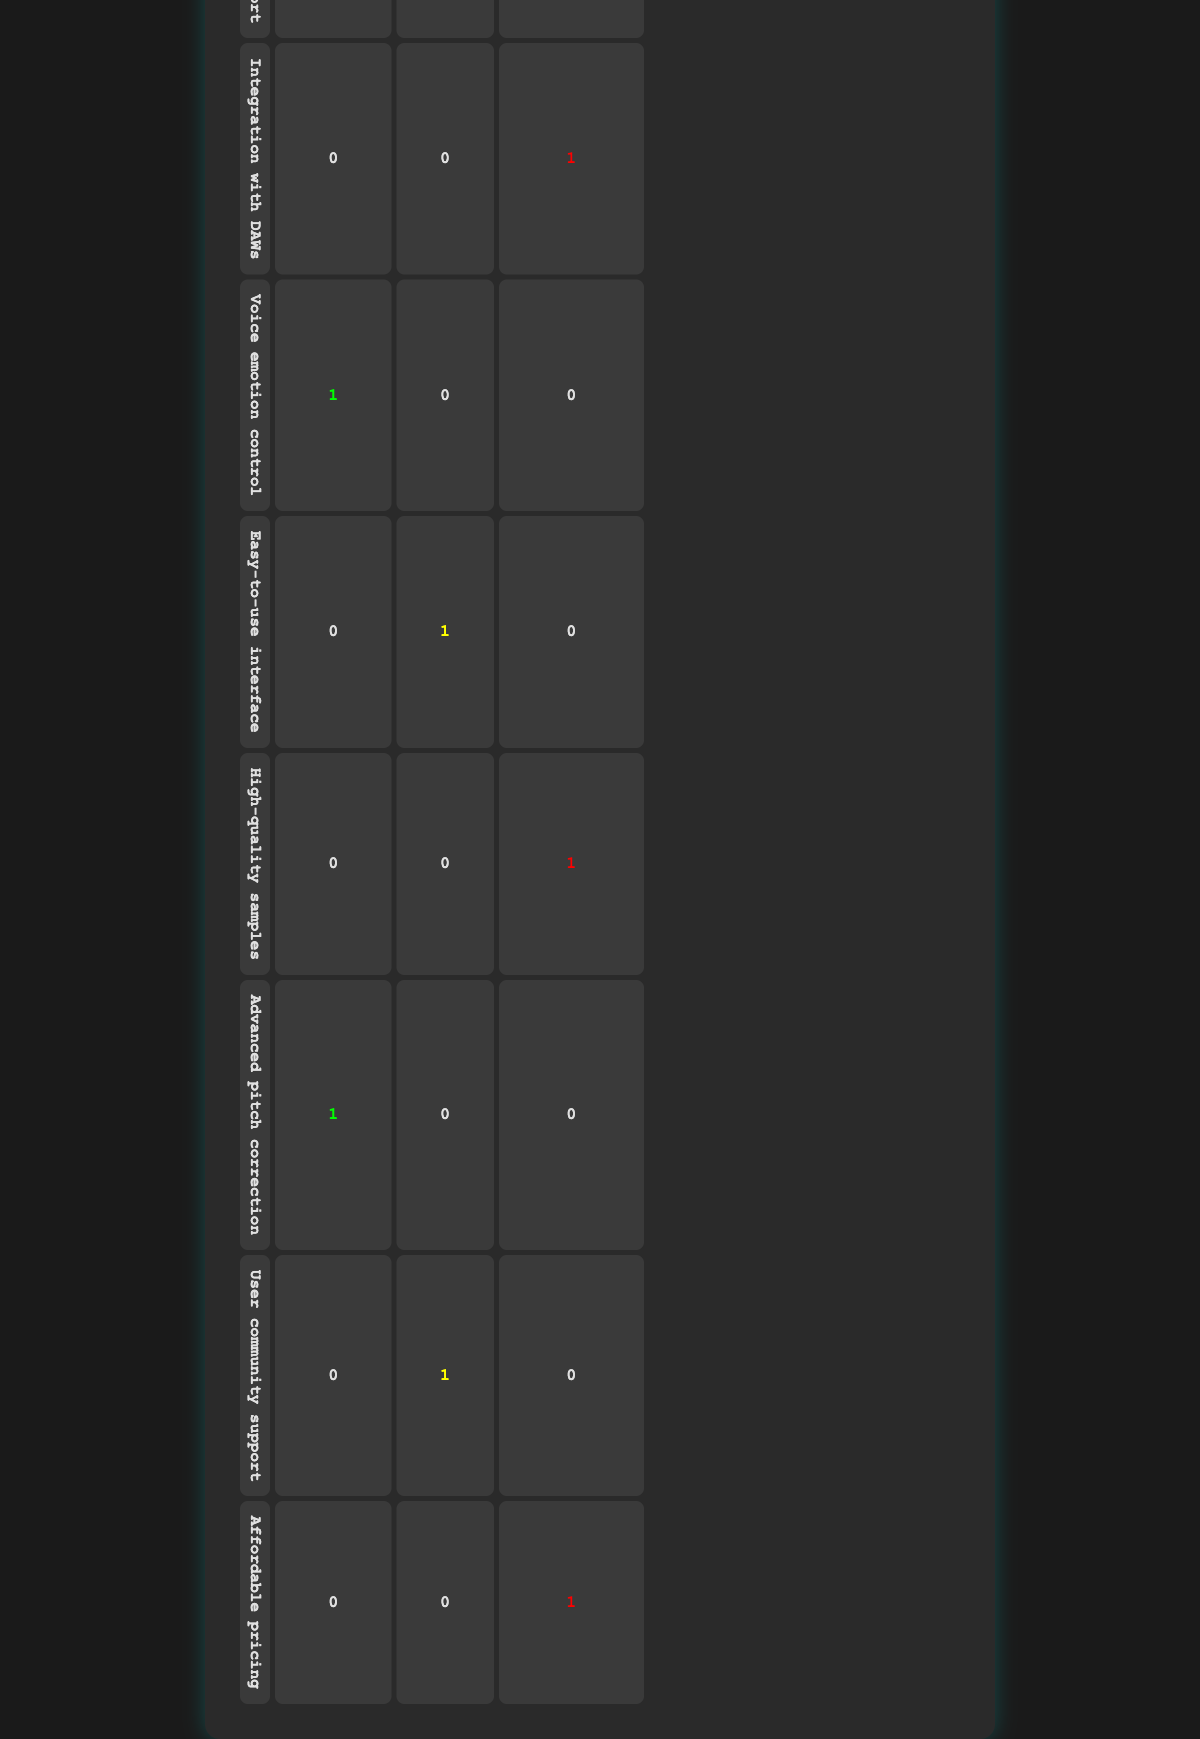What is the total number of users who are satisfied with "Realistic voice modulation"? Referring to the table, there is 1 user who is satisfied with "Realistic voice modulation," indicated in the "Satisfied" column under that feature.
Answer: 1 How many users expected "Customizable vocal styles"? The table shows that there is 1 user (user_id 2) who expected "Customizable vocal styles" and is marked as dissatisfied.
Answer: 1 What is the most common user sentiment for "Advanced pitch correction"? For "Advanced pitch correction," there are 1 user who is satisfied and no users who are neutral or dissatisfied, making "Satisfied" the most common sentiment.
Answer: Satisfied How many features received no "Neutral" feedback? By examining the table, we see that "Realistic voice modulation," "Multi-language support," "Voice emotion control," and "Advanced pitch correction" received no neutral feedback (0). Counting these gives us 4 features with no neutral feedback.
Answer: 4 Is there any feature that received both satisfied and dissatisfied feedback? Looking at the table, each feature only received satisfaction or dissatisfaction feedback, not both, confirming that there is no feature that received mixed feedback.
Answer: No What is the percentage of users who expressed dissatisfaction among the total users? There are 10 users in total, and 4 users expressed dissatisfaction (with features: "Customizable vocal styles," "Integration with DAWs," "High-quality samples," and "Affordable pricing"). To calculate the percentage, divide the number of dissatisfied users by the total (4/10) and multiply by 100, resulting in 40%.
Answer: 40% Which expected feature has the highest number of dissatisfied users? Examining the table, "Customizable vocal styles," "Integration with DAWs," "High-quality samples," and "Affordable pricing" each have 1 dissatisfied user. However, there is no distinction among them since they all share the same count of dissatisfaction.
Answer: All have equal dissatisfaction What is the total number of neutral responses across all features? By looking at the table, the neutral responses can be found for "Easy-to-use interface" (1) and "User community support" (1), totaling 2 neutral responses across the reported features.
Answer: 2 Which feature is most associated with satisfaction? Analyzing the table, the features "Realistic voice modulation," "Multi-language support," "Voice emotion control," and "Advanced pitch correction" each received 1 satisfied response, but there is no feature that stands out more than these as all are equally associated with satisfaction.
Answer: All are equal 